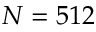<formula> <loc_0><loc_0><loc_500><loc_500>N = 5 1 2</formula> 